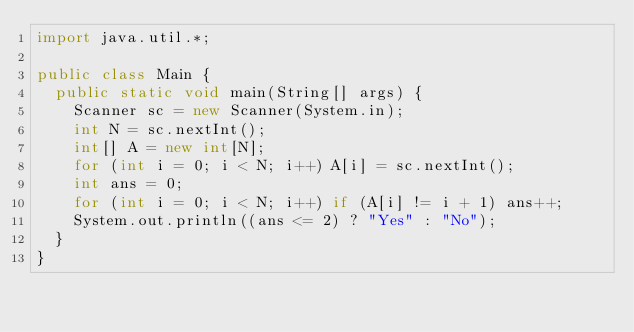<code> <loc_0><loc_0><loc_500><loc_500><_Java_>import java.util.*;

public class Main {
  public static void main(String[] args) {
    Scanner sc = new Scanner(System.in);
    int N = sc.nextInt();
    int[] A = new int[N];
    for (int i = 0; i < N; i++) A[i] = sc.nextInt();
    int ans = 0;
    for (int i = 0; i < N; i++) if (A[i] != i + 1) ans++;
    System.out.println((ans <= 2) ? "Yes" : "No");
  }
}</code> 